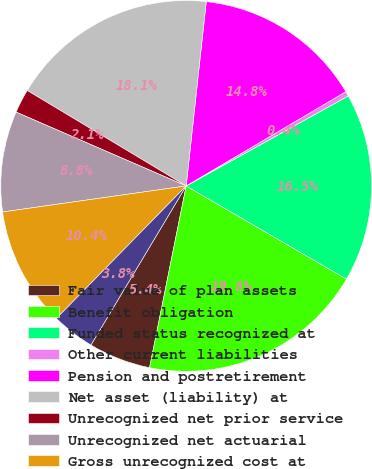Convert chart to OTSL. <chart><loc_0><loc_0><loc_500><loc_500><pie_chart><fcel>Fair value of plan assets<fcel>Benefit obligation<fcel>Funded status recognized at<fcel>Other current liabilities<fcel>Pension and postretirement<fcel>Net asset (liability) at<fcel>Unrecognized net prior service<fcel>Unrecognized net actuarial<fcel>Gross unrecognized cost at<fcel>Deferred tax asset at December<nl><fcel>5.42%<fcel>19.78%<fcel>16.45%<fcel>0.42%<fcel>14.78%<fcel>18.12%<fcel>2.09%<fcel>8.76%<fcel>10.42%<fcel>3.75%<nl></chart> 